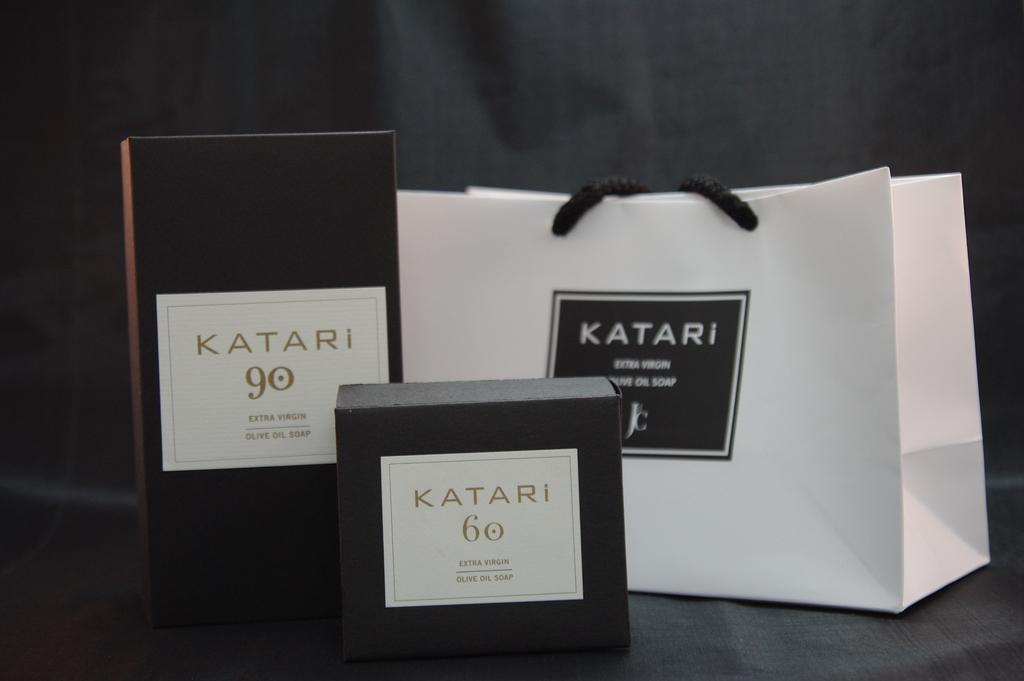<image>
Share a concise interpretation of the image provided. Three items sitting on a table advertising Katari. 